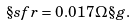<formula> <loc_0><loc_0><loc_500><loc_500>\S s f r = 0 . 0 1 7 \, \Omega \S g .</formula> 